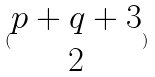Convert formula to latex. <formula><loc_0><loc_0><loc_500><loc_500>( \begin{matrix} p + q + 3 \\ 2 \end{matrix} )</formula> 